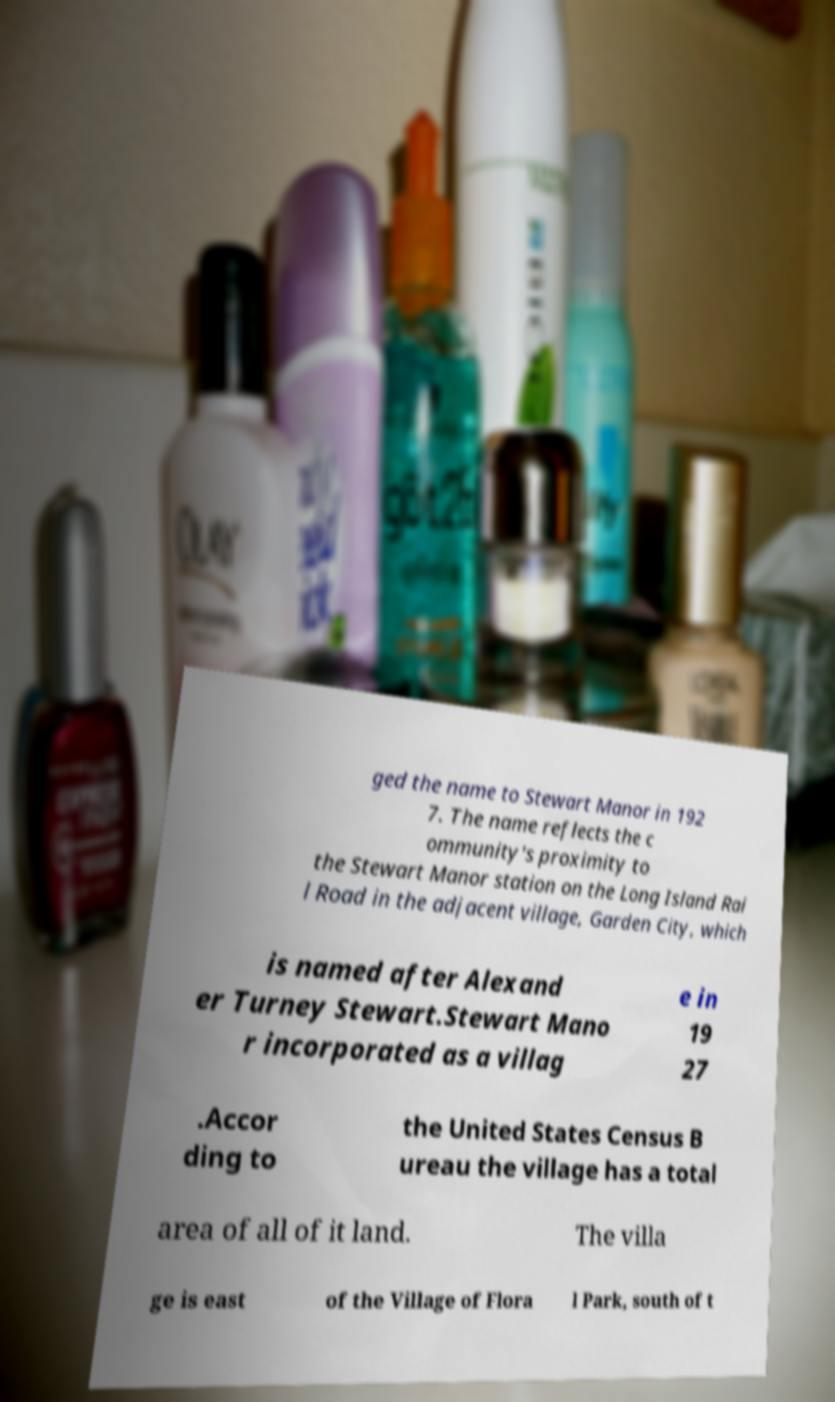Can you accurately transcribe the text from the provided image for me? ged the name to Stewart Manor in 192 7. The name reflects the c ommunity's proximity to the Stewart Manor station on the Long Island Rai l Road in the adjacent village, Garden City, which is named after Alexand er Turney Stewart.Stewart Mano r incorporated as a villag e in 19 27 .Accor ding to the United States Census B ureau the village has a total area of all of it land. The villa ge is east of the Village of Flora l Park, south of t 